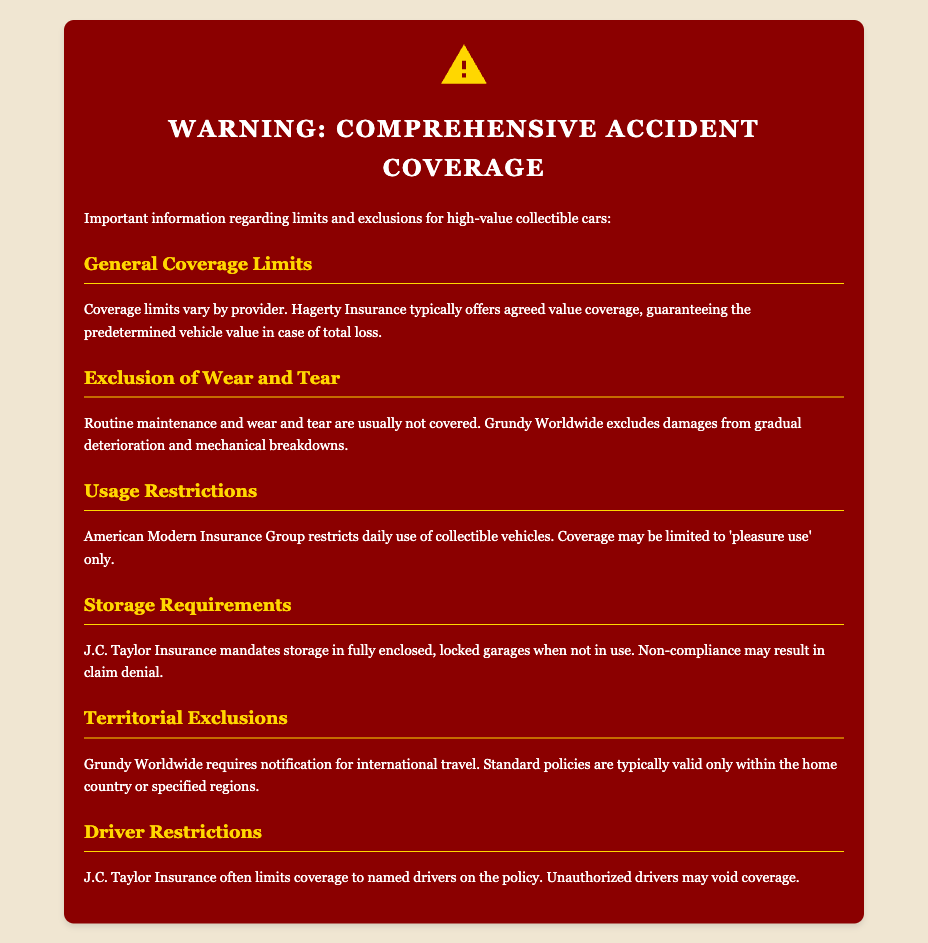What is the coverage type typically offered by Hagerty Insurance? Hagerty Insurance typically offers agreed value coverage, which guarantees the predetermined vehicle value in case of total loss.
Answer: agreed value coverage What does Grundy Worldwide exclude from coverage? Grundy Worldwide excludes damages from gradual deterioration and mechanical breakdowns, which refers to wear and tear.
Answer: wear and tear What is the storage requirement mandated by J.C. Taylor Insurance? J.C. Taylor Insurance mandates storage in fully enclosed, locked garages when the vehicle is not in use.
Answer: locked garages What type of use does American Modern Insurance Group allow for collectible vehicles? American Modern Insurance Group restricts daily use of collectible vehicles and may limit coverage to 'pleasure use' only.
Answer: pleasure use What must be notified to Grundy Worldwide while traveling? Grundy Worldwide requires notification for international travel, indicating their policy is only valid within specific regions.
Answer: international travel How does J.C. Taylor Insurance handle driver restrictions? J.C. Taylor Insurance often limits coverage to named drivers on the policy, meaning unauthorized drivers may void coverage.
Answer: named drivers What are the usual coverage limits? Coverage limits vary by provider, which should be noted for policyholders of high-value collectible cars.
Answer: vary by provider What type of policy does Grundy Worldwide typically offer for territories? Standard policies from Grundy Worldwide are typically valid only within the home country or specified regions.
Answer: home country 